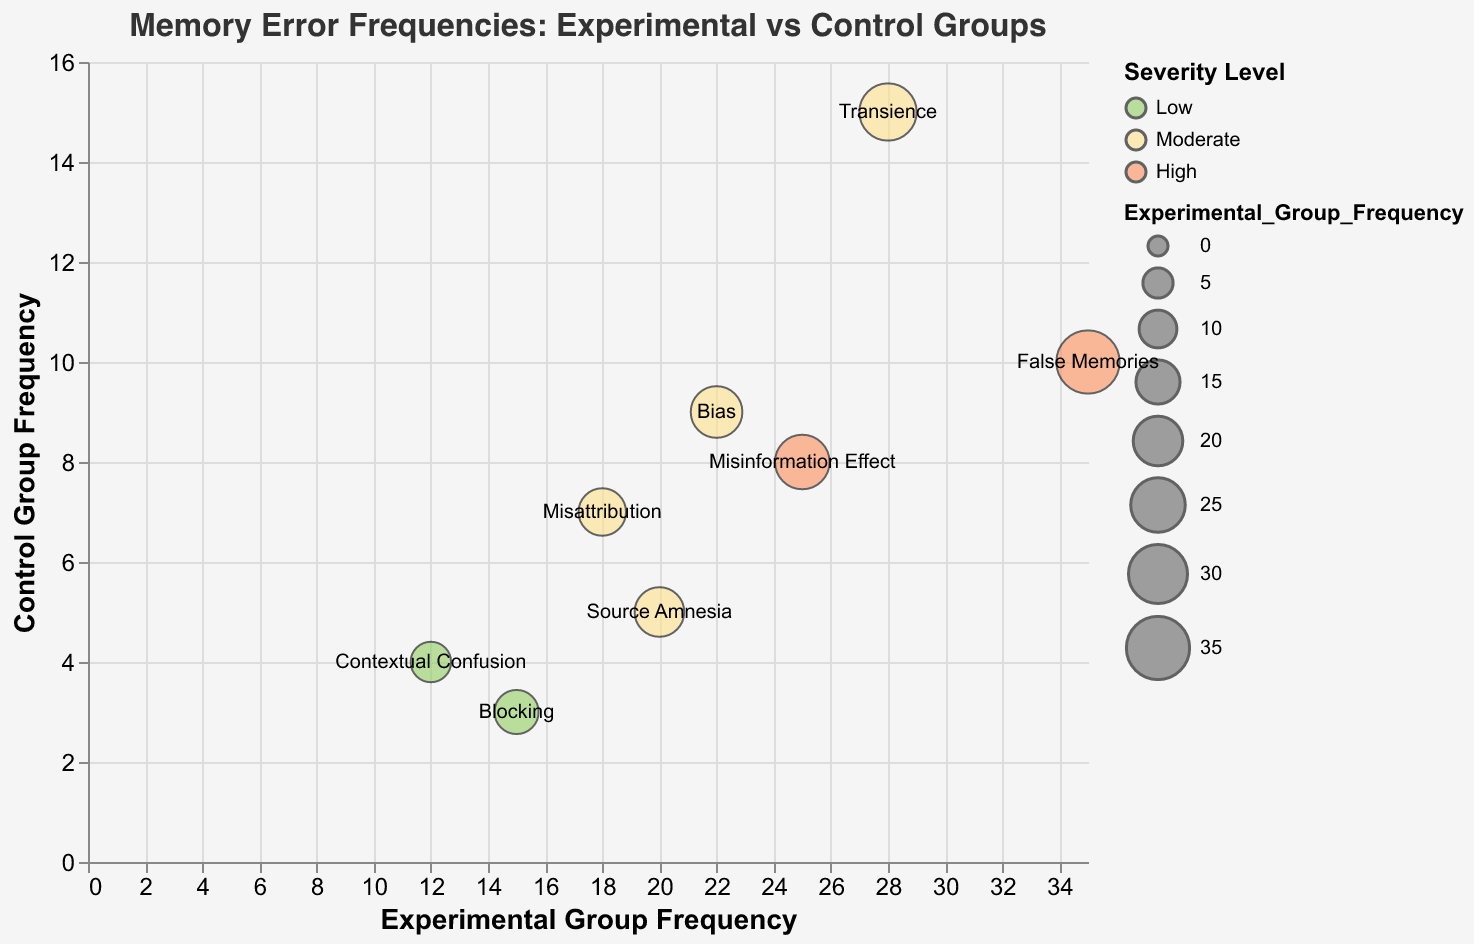What is the title of the chart? The title is written at the top of the chart.
Answer: Memory Error Frequencies: Experimental vs Control Groups How many memory error types are being compared in this chart? Each circle represents a memory error type, and there are labels for each one. Count the number of unique labels.
Answer: 8 Which memory error type has the highest frequency in the experimental group? Look for the circle positioned farthest to the right along the x-axis, noting its label.
Answer: False Memories How does the frequency of "Contextual Confusion" in the control group compare to the experimental group? Identify the circles labeled "Contextual Confusion" and compare their y-axis (control group) and x-axis (experimental group) positions.
Answer: Experimental Group Frequency: 12, Control Group Frequency: 4 What color represents the severity level "High"? Check the color legend on the right side of the chart to identify the color associated with "High".
Answer: Red Which memory error type has a similar frequency in both the experimental and control groups? Look for circles that are close to the x=y diagonal line, indicating similar values for experimental and control groups.
Answer: Transience What is the sum of the frequencies for the "False Memories" error type in both groups? Add the frequencies from the x and y axes for the "False Memories" circle.
Answer: 35 (Experimental) + 10 (Control) = 45 Which memory error type has the lowest frequency in the control group? Find the circle with the lowest y-axis value and note its label.
Answer: Blocking Which error type shows a moderate severity level and has a higher frequency in the experimental group compared to the control group? Look for circles labeled with "Moderate" in the color legend and compare their x and y positions.
Answer: Source Amnesia, Transience, Misattribution, Bias What is the difference in frequency between "Bias" and "Blocking" in the experimental group? Subtract the x-axis values of "Blocking" from "Bias".
Answer: 22 (Bias) - 15 (Blocking) = 7 